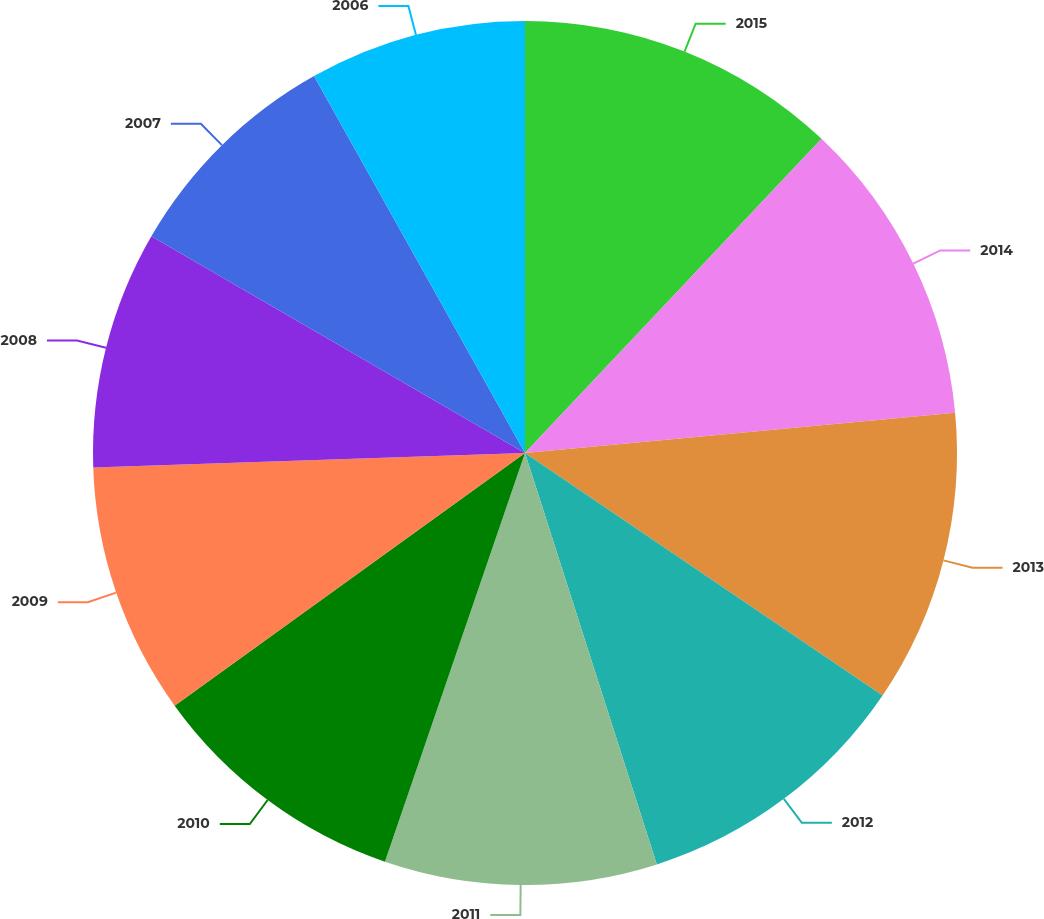Convert chart to OTSL. <chart><loc_0><loc_0><loc_500><loc_500><pie_chart><fcel>2015<fcel>2014<fcel>2013<fcel>2012<fcel>2011<fcel>2010<fcel>2009<fcel>2008<fcel>2007<fcel>2006<nl><fcel>12.04%<fcel>11.47%<fcel>10.97%<fcel>10.58%<fcel>10.19%<fcel>9.8%<fcel>9.41%<fcel>8.9%<fcel>8.51%<fcel>8.12%<nl></chart> 